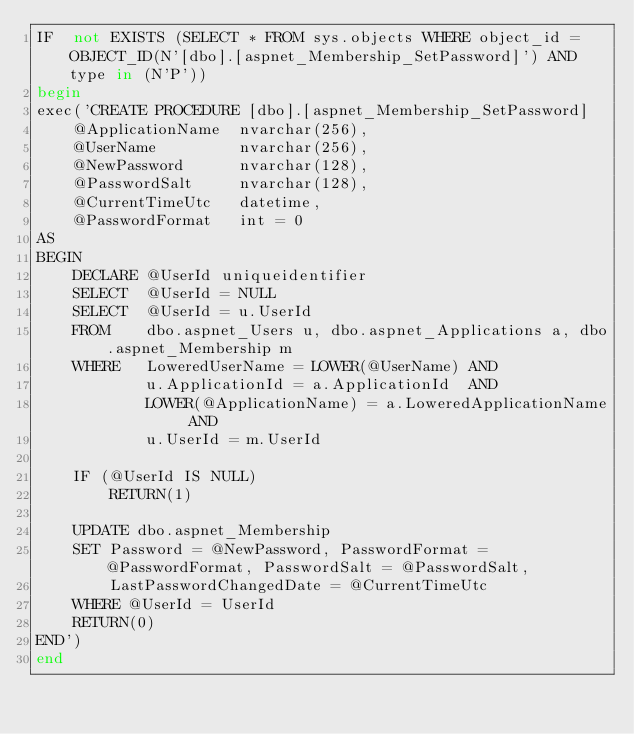Convert code to text. <code><loc_0><loc_0><loc_500><loc_500><_SQL_>IF  not EXISTS (SELECT * FROM sys.objects WHERE object_id = OBJECT_ID(N'[dbo].[aspnet_Membership_SetPassword]') AND type in (N'P'))
begin
exec('CREATE PROCEDURE [dbo].[aspnet_Membership_SetPassword]
    @ApplicationName  nvarchar(256),
    @UserName         nvarchar(256),
    @NewPassword      nvarchar(128),
    @PasswordSalt     nvarchar(128),
    @CurrentTimeUtc   datetime,
    @PasswordFormat   int = 0
AS
BEGIN
    DECLARE @UserId uniqueidentifier
    SELECT  @UserId = NULL
    SELECT  @UserId = u.UserId
    FROM    dbo.aspnet_Users u, dbo.aspnet_Applications a, dbo.aspnet_Membership m
    WHERE   LoweredUserName = LOWER(@UserName) AND
            u.ApplicationId = a.ApplicationId  AND
            LOWER(@ApplicationName) = a.LoweredApplicationName AND
            u.UserId = m.UserId

    IF (@UserId IS NULL)
        RETURN(1)

    UPDATE dbo.aspnet_Membership
    SET Password = @NewPassword, PasswordFormat = @PasswordFormat, PasswordSalt = @PasswordSalt,
        LastPasswordChangedDate = @CurrentTimeUtc
    WHERE @UserId = UserId
    RETURN(0)
END')
end


</code> 